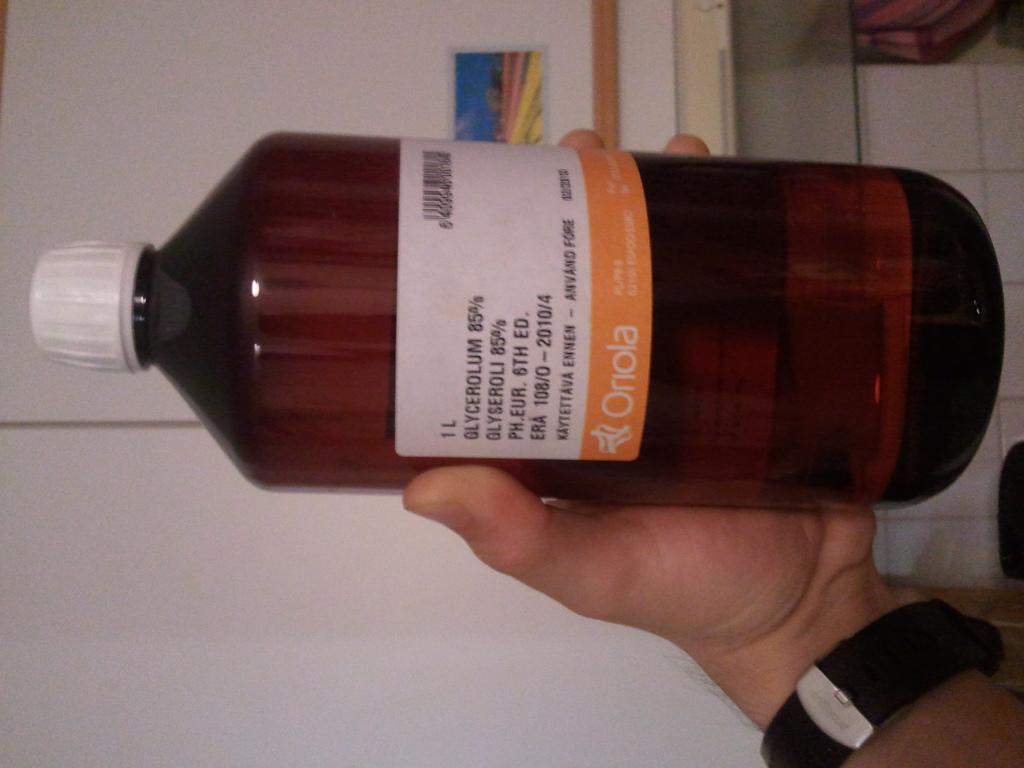Could you give a brief overview of what you see in this image? In this picture we can see a bottle holding with the hand. 